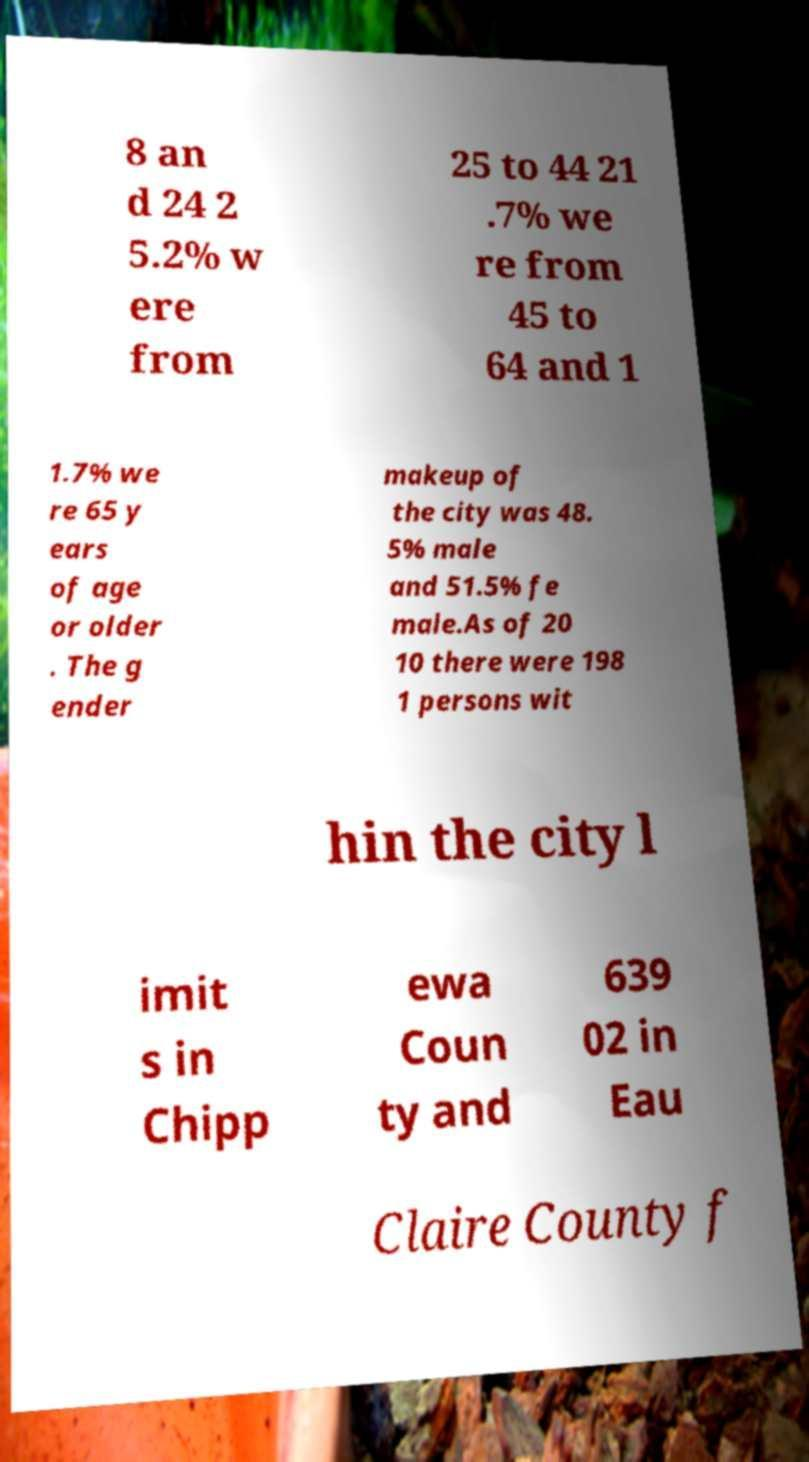There's text embedded in this image that I need extracted. Can you transcribe it verbatim? 8 an d 24 2 5.2% w ere from 25 to 44 21 .7% we re from 45 to 64 and 1 1.7% we re 65 y ears of age or older . The g ender makeup of the city was 48. 5% male and 51.5% fe male.As of 20 10 there were 198 1 persons wit hin the city l imit s in Chipp ewa Coun ty and 639 02 in Eau Claire County f 